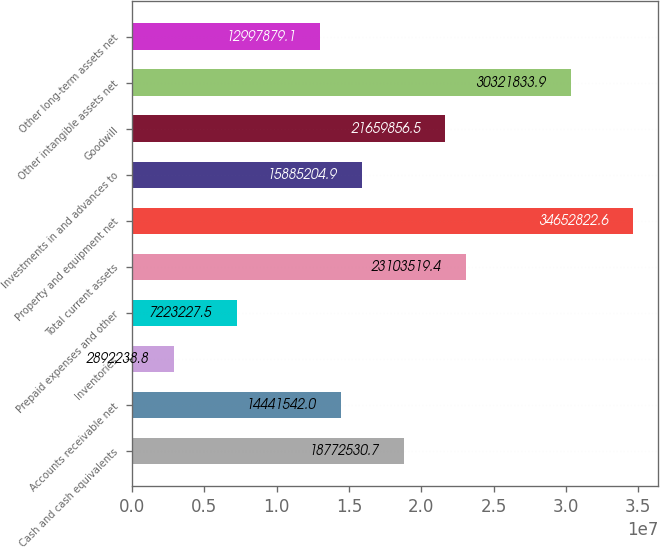Convert chart to OTSL. <chart><loc_0><loc_0><loc_500><loc_500><bar_chart><fcel>Cash and cash equivalents<fcel>Accounts receivable net<fcel>Inventories<fcel>Prepaid expenses and other<fcel>Total current assets<fcel>Property and equipment net<fcel>Investments in and advances to<fcel>Goodwill<fcel>Other intangible assets net<fcel>Other long-term assets net<nl><fcel>1.87725e+07<fcel>1.44415e+07<fcel>2.89224e+06<fcel>7.22323e+06<fcel>2.31035e+07<fcel>3.46528e+07<fcel>1.58852e+07<fcel>2.16599e+07<fcel>3.03218e+07<fcel>1.29979e+07<nl></chart> 